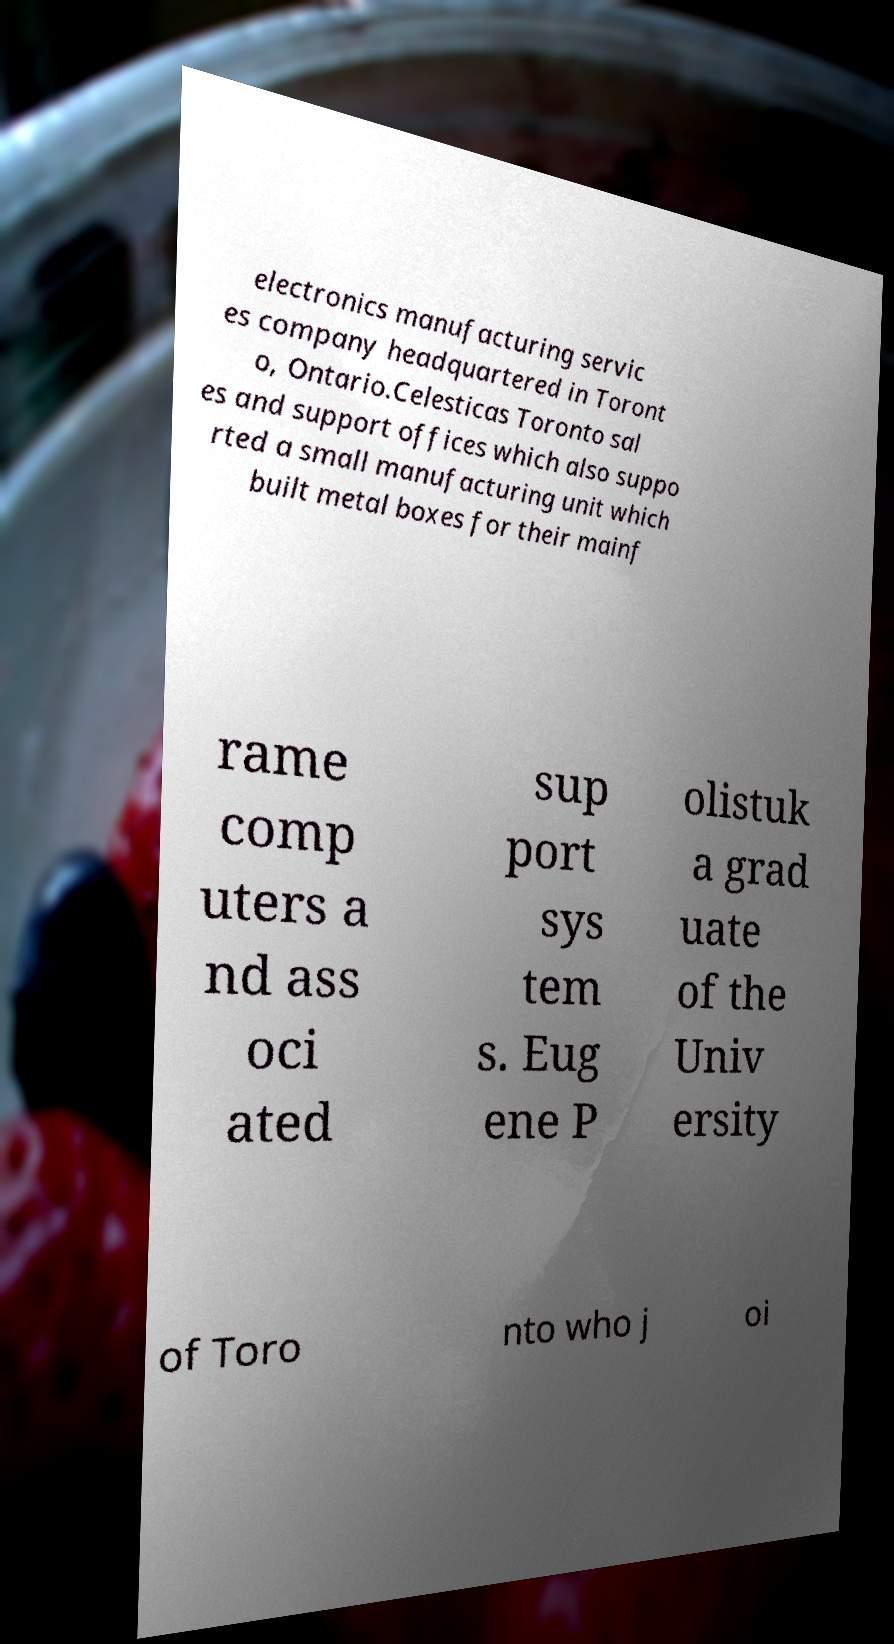Please identify and transcribe the text found in this image. electronics manufacturing servic es company headquartered in Toront o, Ontario.Celesticas Toronto sal es and support offices which also suppo rted a small manufacturing unit which built metal boxes for their mainf rame comp uters a nd ass oci ated sup port sys tem s. Eug ene P olistuk a grad uate of the Univ ersity of Toro nto who j oi 